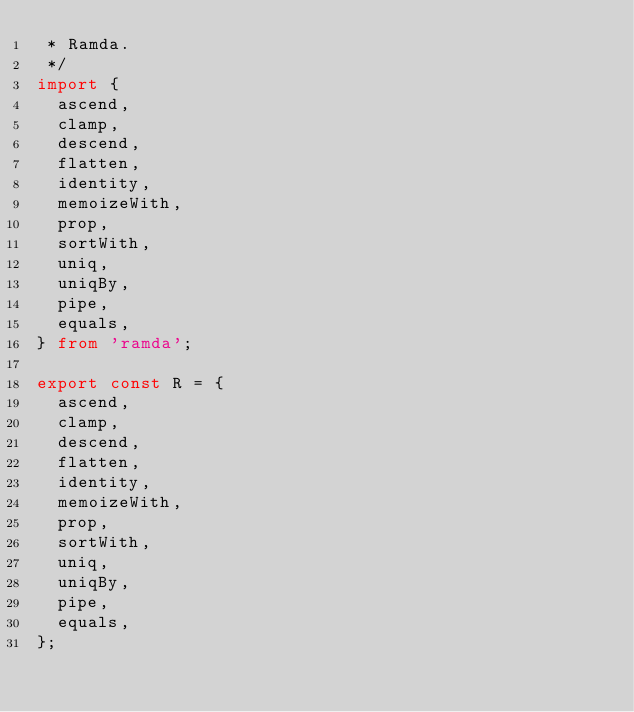Convert code to text. <code><loc_0><loc_0><loc_500><loc_500><_TypeScript_> * Ramda.
 */
import {
  ascend,
  clamp,
  descend,
  flatten,
  identity,
  memoizeWith,
  prop,
  sortWith,
  uniq,
  uniqBy,
  pipe,
  equals,
} from 'ramda';

export const R = {
  ascend,
  clamp,
  descend,
  flatten,
  identity,
  memoizeWith,
  prop,
  sortWith,
  uniq,
  uniqBy,
  pipe,
  equals,
};
</code> 